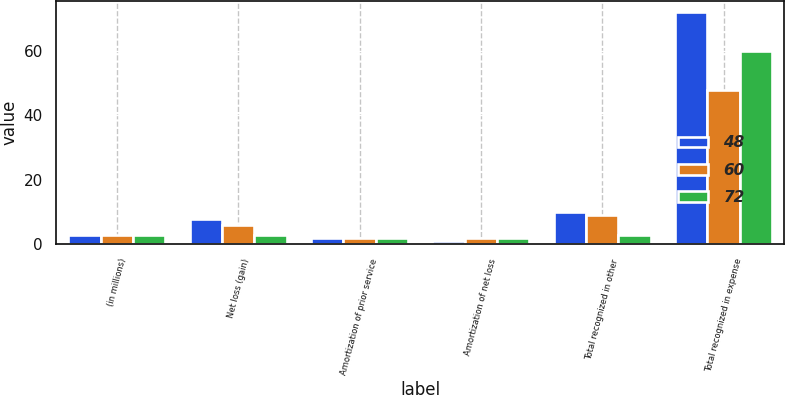<chart> <loc_0><loc_0><loc_500><loc_500><stacked_bar_chart><ecel><fcel>(in millions)<fcel>Net loss (gain)<fcel>Amortization of prior service<fcel>Amortization of net loss<fcel>Total recognized in other<fcel>Total recognized in expense<nl><fcel>48<fcel>3<fcel>8<fcel>2<fcel>1<fcel>10<fcel>72<nl><fcel>60<fcel>3<fcel>6<fcel>2<fcel>2<fcel>9<fcel>48<nl><fcel>72<fcel>3<fcel>3<fcel>2<fcel>2<fcel>3<fcel>60<nl></chart> 